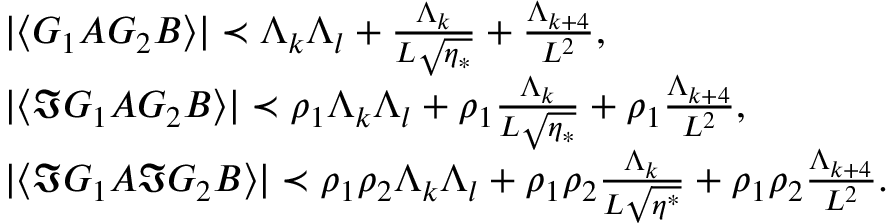<formula> <loc_0><loc_0><loc_500><loc_500>\begin{array} { r l } & { | \langle G _ { 1 } A G _ { 2 } B \rangle | \prec \Lambda _ { k } \Lambda _ { l } + \frac { \Lambda _ { k } } { L \sqrt { \eta _ { * } } } + \frac { \Lambda _ { k + 4 } } { L ^ { 2 } } , \, } \\ & { | \langle \Im G _ { 1 } A G _ { 2 } B \rangle | \prec \rho _ { 1 } \Lambda _ { k } \Lambda _ { l } + \rho _ { 1 } \frac { \Lambda _ { k } } { L \sqrt { \eta _ { * } } } + \rho _ { 1 } \frac { \Lambda _ { k + 4 } } { L ^ { 2 } } , } \\ & { | \langle \Im G _ { 1 } A \Im G _ { 2 } B \rangle | \prec \rho _ { 1 } \rho _ { 2 } \Lambda _ { k } \Lambda _ { l } + \rho _ { 1 } \rho _ { 2 } \frac { \Lambda _ { k } } { L \sqrt { \eta ^ { * } } } + \rho _ { 1 } \rho _ { 2 } \frac { \Lambda _ { k + 4 } } { L ^ { 2 } } . } \end{array}</formula> 